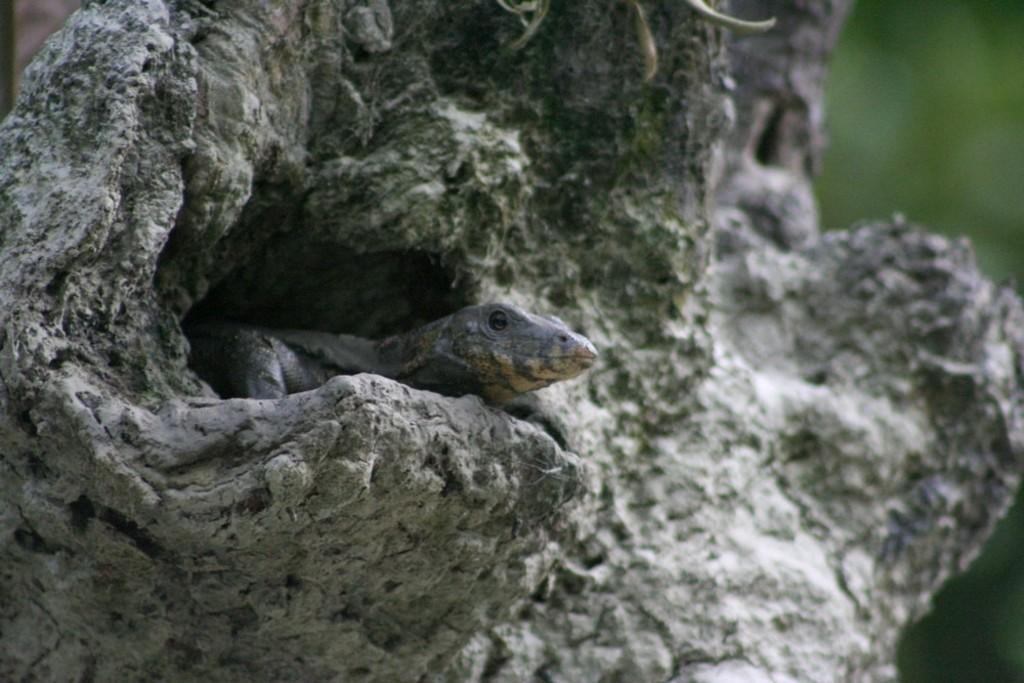What type of animal is in the image? There is a lizard in the image. Where is the lizard located? The lizard is inside a wooden hole. What type of veil is covering the lizard in the image? There is no veil present in the image; the lizard is inside a wooden hole. 